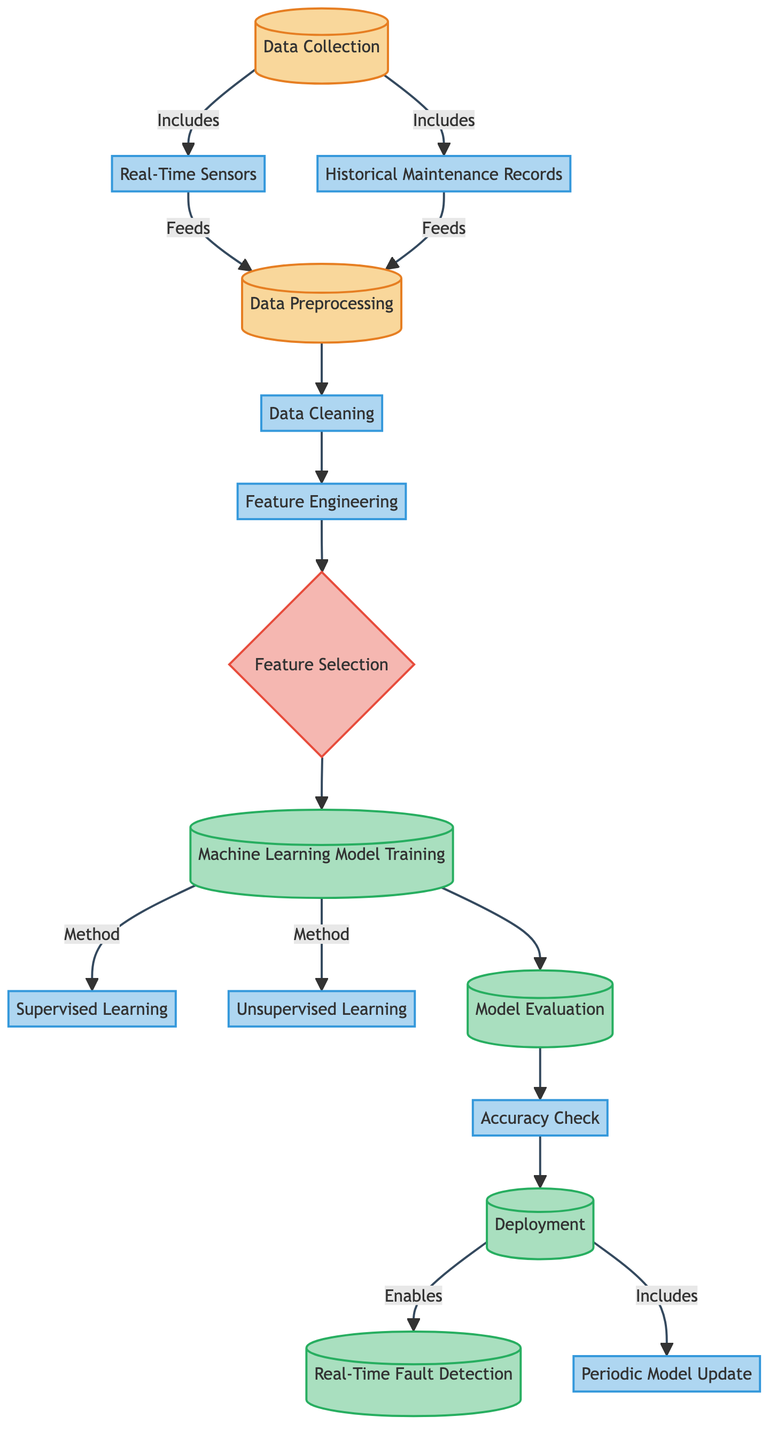What are the two types of machine learning methods used in the training phase? The diagram lists "Supervised Learning" and "Unsupervised Learning" as the two methods under the "Machine Learning Model Training" node.
Answer: Supervised Learning, Unsupervised Learning How many input nodes are present in the diagram? There are three input nodes: "Data Collection", "Data Preprocessing", and "Feature Selection". Counting these provides the answer.
Answer: 3 What is the first step after data preprocessing? The next step indicated after "Data Preprocessing" is "Data Cleaning", which directly follows it in the flow.
Answer: Data Cleaning Which node links Real-Time Fault Detection and Deployment? The "Deployment" node connects with "Real-Time Fault Detection", showing that deployment enables real-time fault detection.
Answer: Deployment What is required for the model evaluation phase? The "Accuracy Check" node is required after model training before moving forward to deployment, confirming the necessity for evaluation.
Answer: Accuracy Check What node is followed after Feature Engineering? The "Feature Selection" node directly follows "Feature Engineering", indicating the next step in the process flow.
Answer: Feature Selection How many edges connect the nodes in the diagram? By counting the arrows between nodes in the diagram, a total of 12 edges can be found.
Answer: 12 Which processes feed into Data Preprocessing? The processes "Real-Time Sensors" and "Historical Maintenance Records" both feed into "Data Preprocessing". By observing the arrows, this can be confirmed.
Answer: Real-Time Sensors, Historical Maintenance Records Which node signifies the final step of periodic updates? The node "Periodic Model Update" indicates continuous improvement following the deployment of the model, marking the ongoing nature of the process.
Answer: Periodic Model Update 